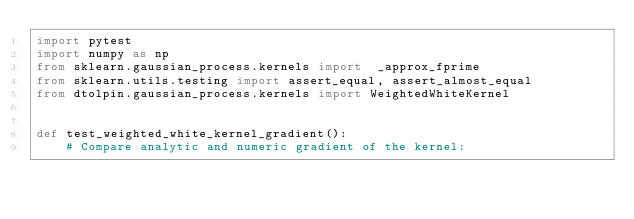<code> <loc_0><loc_0><loc_500><loc_500><_Python_>import pytest
import numpy as np
from sklearn.gaussian_process.kernels import  _approx_fprime
from sklearn.utils.testing import assert_equal, assert_almost_equal
from dtolpin.gaussian_process.kernels import WeightedWhiteKernel


def test_weighted_white_kernel_gradient():
    # Compare analytic and numeric gradient of the kernel:</code> 